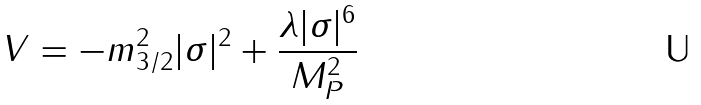Convert formula to latex. <formula><loc_0><loc_0><loc_500><loc_500>V = - m _ { 3 / 2 } ^ { 2 } | \sigma | ^ { 2 } + \frac { \lambda | \sigma | ^ { 6 } } { M _ { P } ^ { 2 } }</formula> 